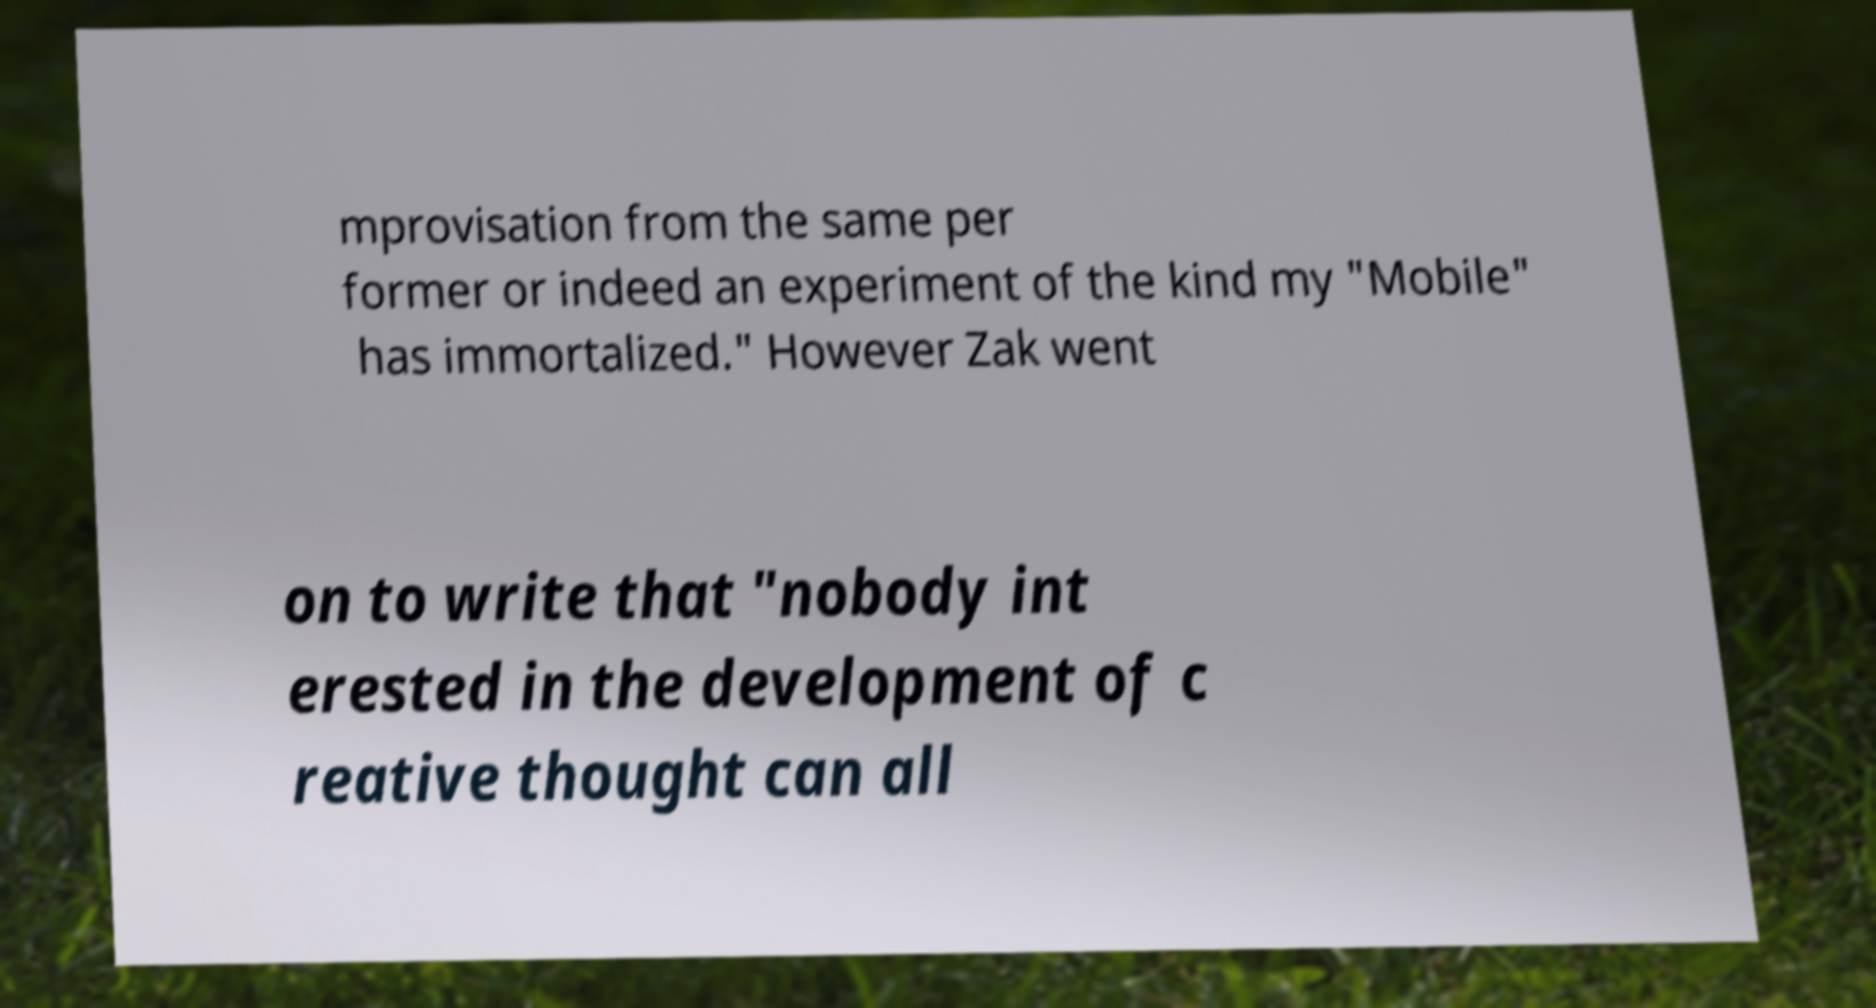Please identify and transcribe the text found in this image. mprovisation from the same per former or indeed an experiment of the kind my "Mobile" has immortalized." However Zak went on to write that "nobody int erested in the development of c reative thought can all 